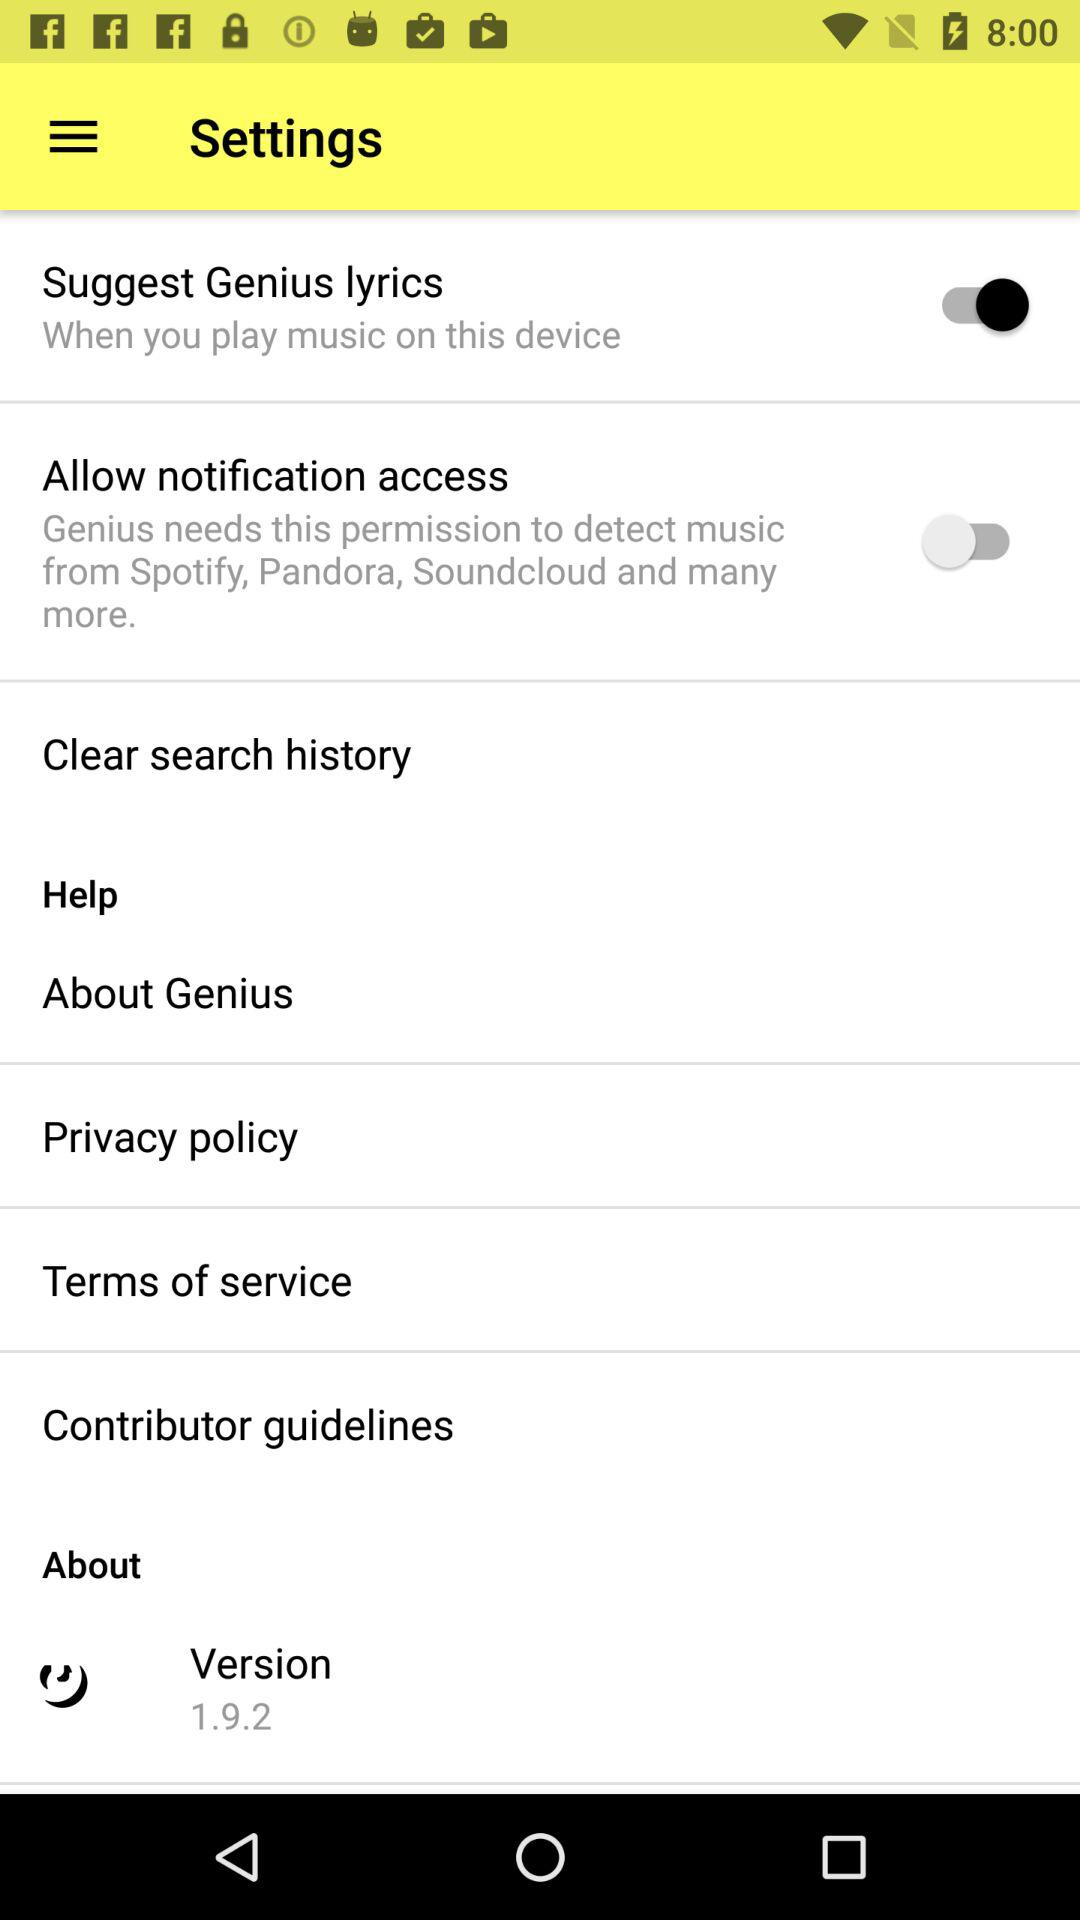What application is asking for permission to detect music from Spotify, Pandora, Soundcloud and many more? The application is "Genius". 